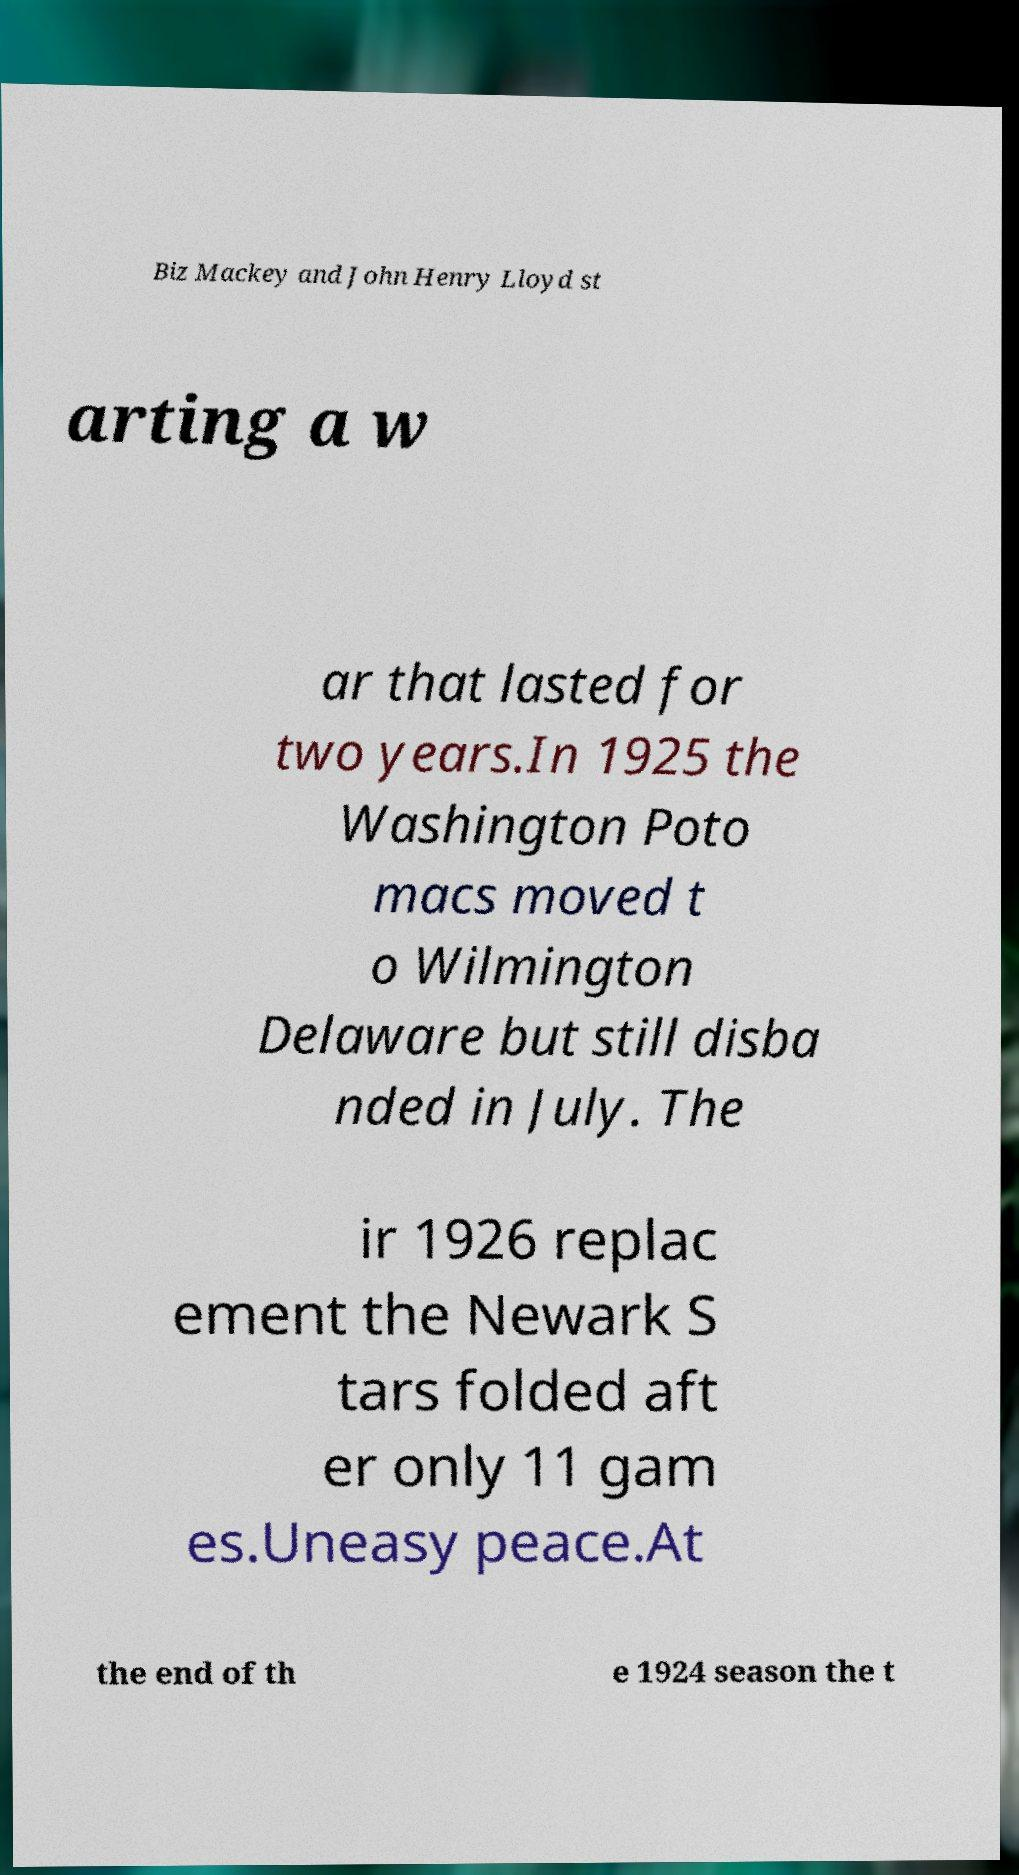Please identify and transcribe the text found in this image. Biz Mackey and John Henry Lloyd st arting a w ar that lasted for two years.In 1925 the Washington Poto macs moved t o Wilmington Delaware but still disba nded in July. The ir 1926 replac ement the Newark S tars folded aft er only 11 gam es.Uneasy peace.At the end of th e 1924 season the t 